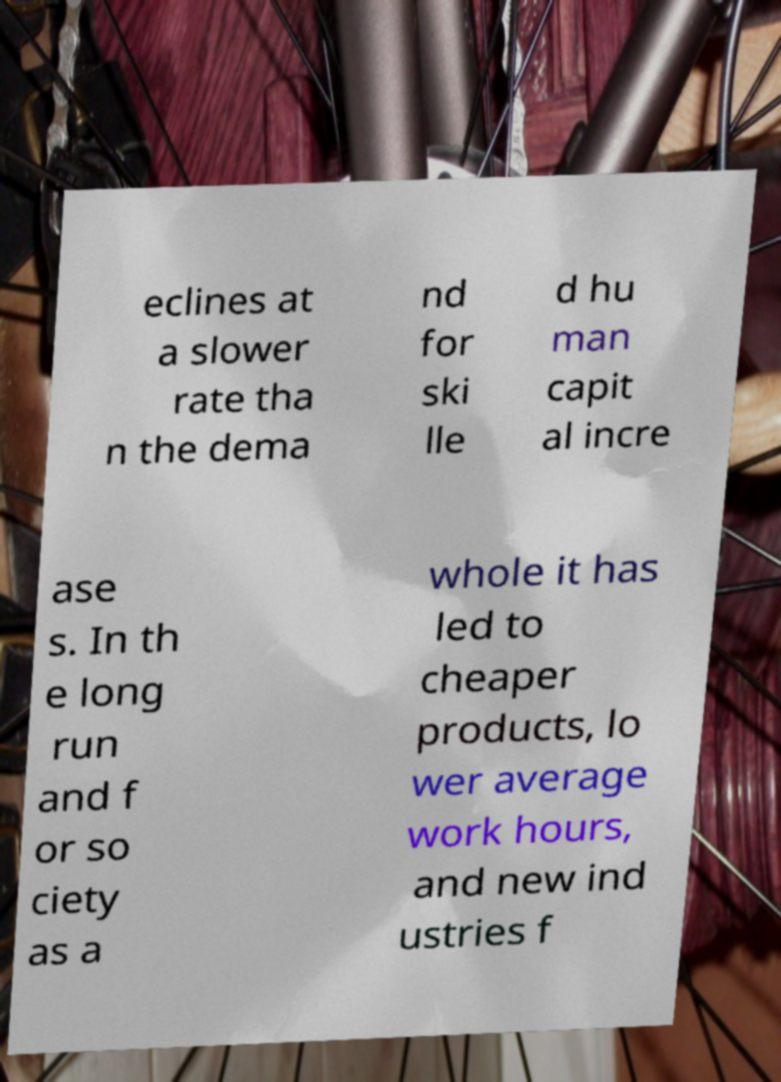Can you accurately transcribe the text from the provided image for me? eclines at a slower rate tha n the dema nd for ski lle d hu man capit al incre ase s. In th e long run and f or so ciety as a whole it has led to cheaper products, lo wer average work hours, and new ind ustries f 